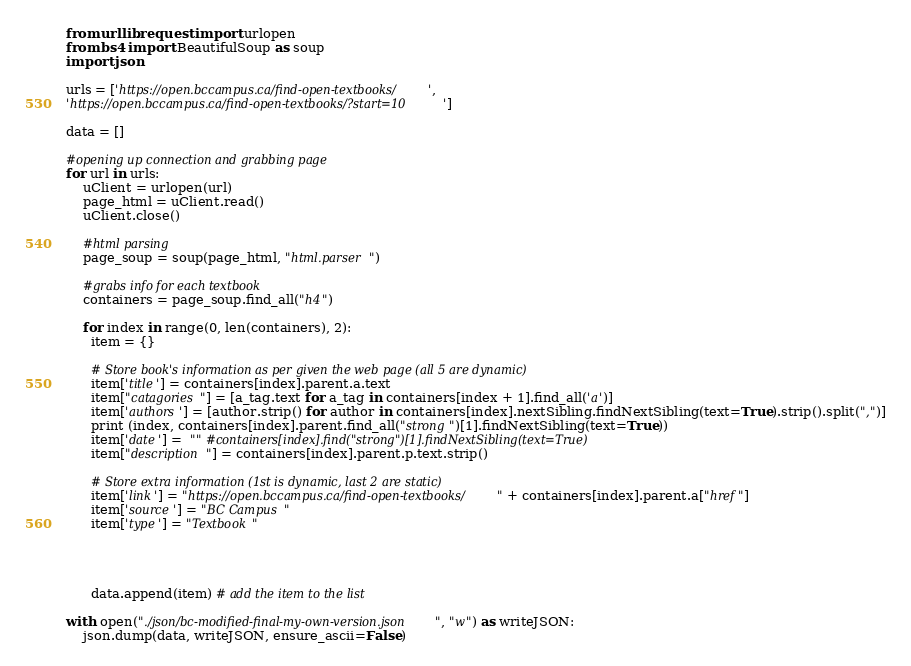<code> <loc_0><loc_0><loc_500><loc_500><_Python_>from urllib.request import urlopen
from bs4 import BeautifulSoup as soup
import json

urls = ['https://open.bccampus.ca/find-open-textbooks/', 
'https://open.bccampus.ca/find-open-textbooks/?start=10']

data = []

#opening up connection and grabbing page
for url in urls:
    uClient = urlopen(url)
    page_html = uClient.read()
    uClient.close()

    #html parsing
    page_soup = soup(page_html, "html.parser")

    #grabs info for each textbook
    containers = page_soup.find_all("h4")
    
    for index in range(0, len(containers), 2):
      item = {}
      
      # Store book's information as per given the web page (all 5 are dynamic)
      item['title'] = containers[index].parent.a.text
      item["catagories"] = [a_tag.text for a_tag in containers[index + 1].find_all('a')]
      item['authors'] = [author.strip() for author in containers[index].nextSibling.findNextSibling(text=True).strip().split(",")]
      print (index, containers[index].parent.find_all("strong")[1].findNextSibling(text=True))
      item['date'] =  "" #containers[index].find("strong")[1].findNextSibling(text=True)
      item["description"] = containers[index].parent.p.text.strip()

      # Store extra information (1st is dynamic, last 2 are static)
      item['link'] = "https://open.bccampus.ca/find-open-textbooks/" + containers[index].parent.a["href"]
      item['source'] = "BC Campus"
      item['type'] = "Textbook"
      
     
      
      
      data.append(item) # add the item to the list

with open("./json/bc-modified-final-my-own-version.json", "w") as writeJSON:
    json.dump(data, writeJSON, ensure_ascii=False)</code> 